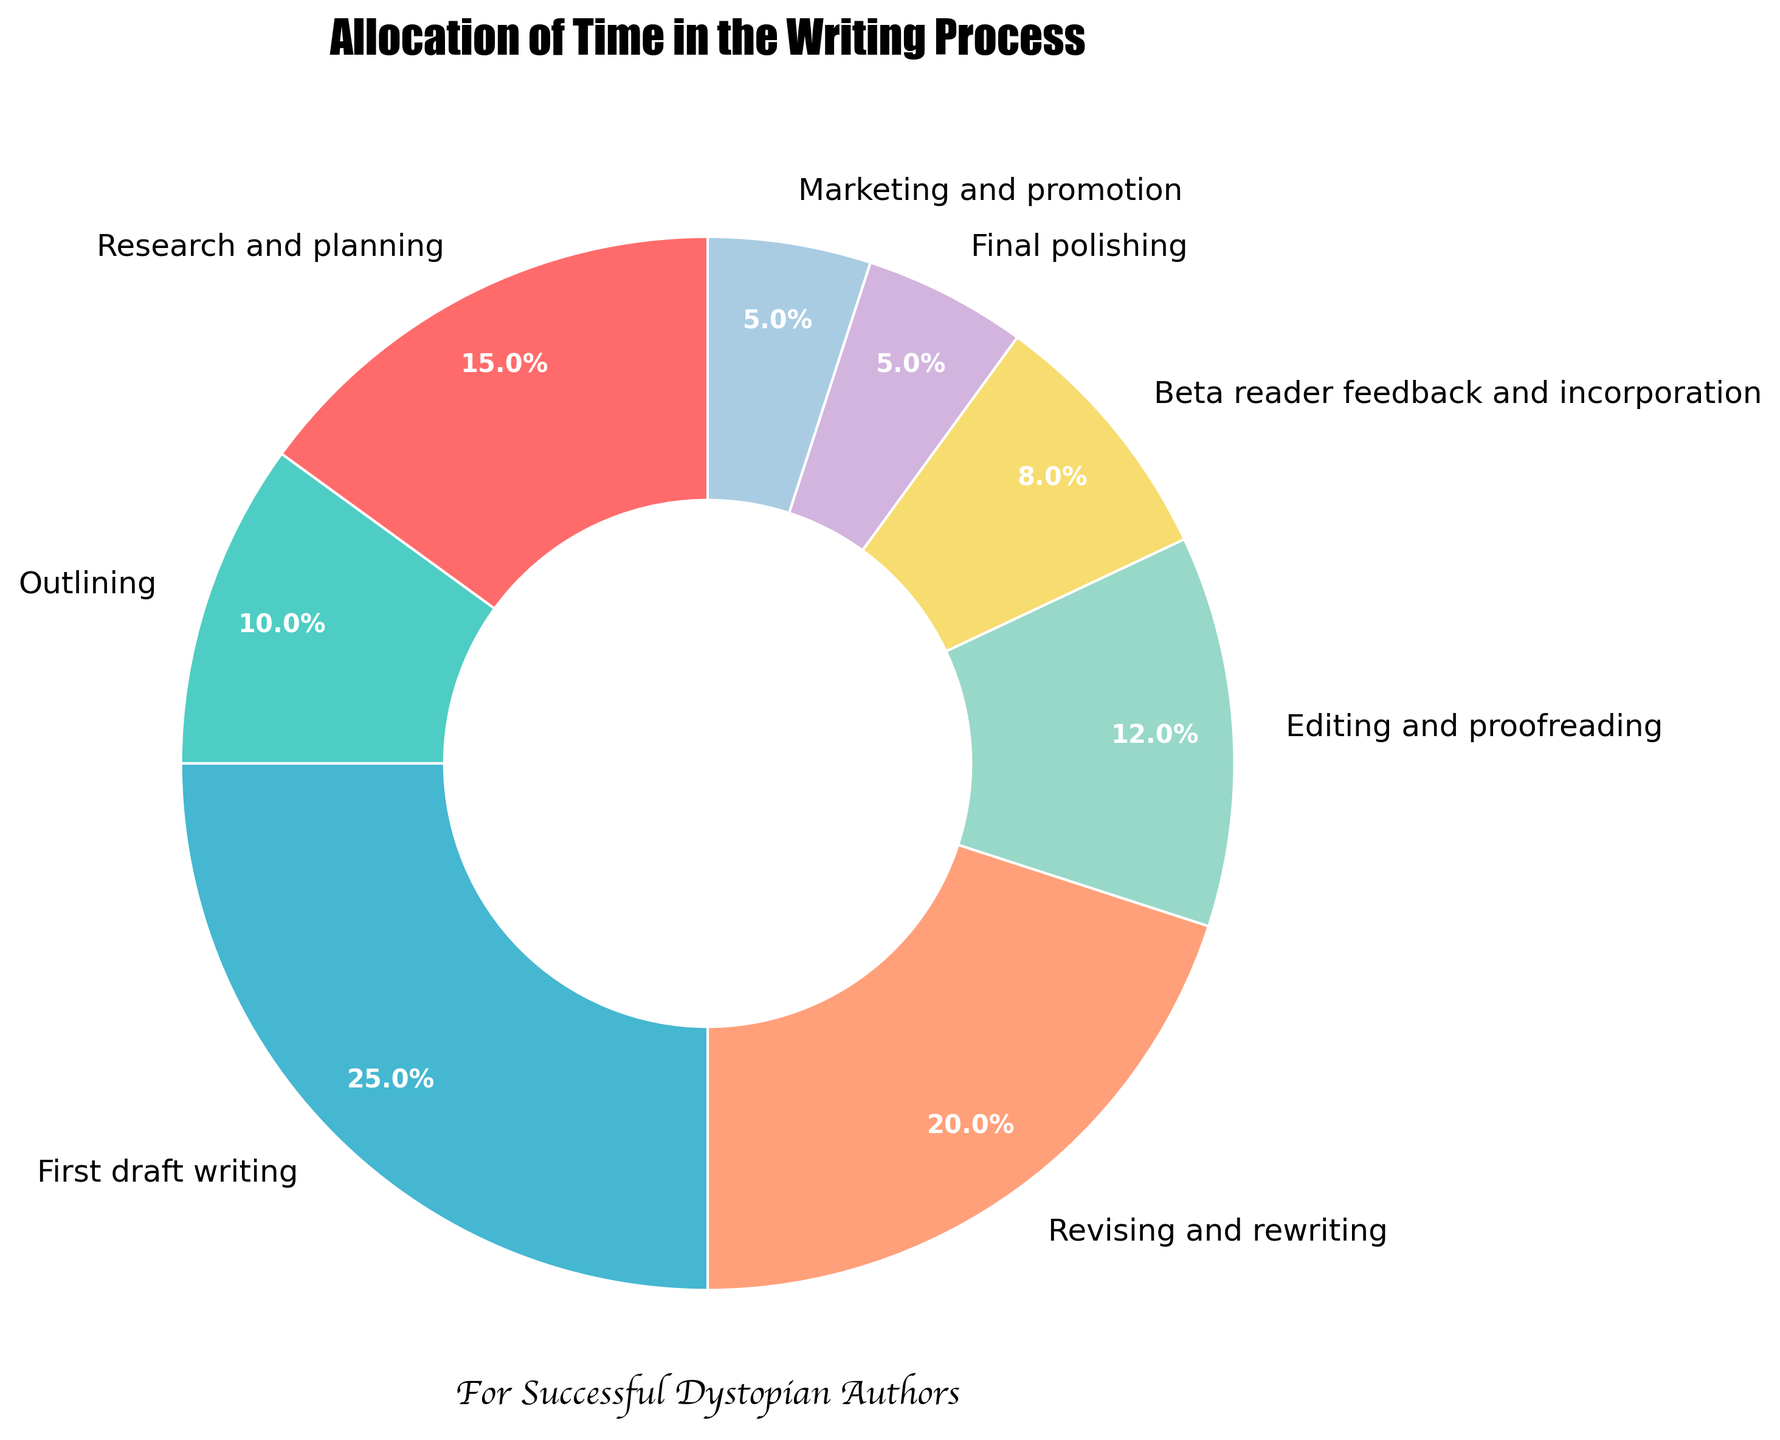What percentage of time is spent on 'Research and planning' and 'Outlining' combined? In the pie chart, 'Research and planning' is allocated 15% and 'Outlining' is allocated 10%. Adding these together results in 15% + 10% = 25%.
Answer: 25% Which stage takes the smallest allocation of time? According to the pie chart, 'Final polishing' and 'Marketing and promotion' both take the smallest allocation of time at 5% each.
Answer: Final polishing and Marketing and promotion Which stage takes more time, 'Beta reader feedback and incorporation' or 'Editing and proofreading'? The pie chart shows 'Beta reader feedback and incorporation' with 8% and 'Editing and proofreading' with 12%. Since 12% is greater than 8%, 'Editing and proofreading' takes more time.
Answer: Editing and proofreading How much more percentage of time is spent on 'First draft writing' compared to 'Final polishing'? 'First draft writing' is allocated 25% of the time and 'Final polishing' is allocated 5%. The difference between them is 25% - 5% = 20%.
Answer: 20% What is the average percentage allocated across all stages? There are 8 stages with the percentages: 15%, 10%, 25%, 20%, 12%, 8%, 5%, 5%. The sum of these percentages is 100%. The average is calculated by dividing the sum by the number of stages: 100% / 8 = 12.5%.
Answer: 12.5% Which stage is allocated the second highest percentage of time? 'First draft writing' is the highest at 25%. The second highest is 'Revising and rewriting' at 20%.
Answer: Revising and rewriting How do the time allocations for 'Revising and rewriting' and 'Beta reader feedback and incorporation' differ? 'Revising and rewriting' is allocated 20% and 'Beta reader feedback and incorporation' is allocated 8%. The difference is 20% - 8% = 12%.
Answer: 12% If 'Final polishing' time were doubled, what would its new allocation be? 'Final polishing' is currently at 5%. Doubling this amount would be 5% * 2 = 10%.
Answer: 10% Is the allocation of time for 'Editing and proofreading' equal to the combined time for 'Beta reader feedback and incorporation' and 'Final polishing'? 'Editing and proofreading' is allocated 12%. The combined time for 'Beta reader feedback and incorporation' and 'Final polishing' is 8% + 5% = 13%. Since 12% is not equal to 13%, they are not equal.
Answer: No What is the total time spent on stages after 'First draft writing'? The stages after 'First draft writing' are 'Revising and rewriting', 'Editing and proofreading', 'Beta reader feedback and incorporation', 'Final polishing', and 'Marketing and promotion', which are allocated 20%, 12%, 8%, 5%, and 5% respectively. The total is 20% + 12% + 8% + 5% + 5% = 50%.
Answer: 50% 